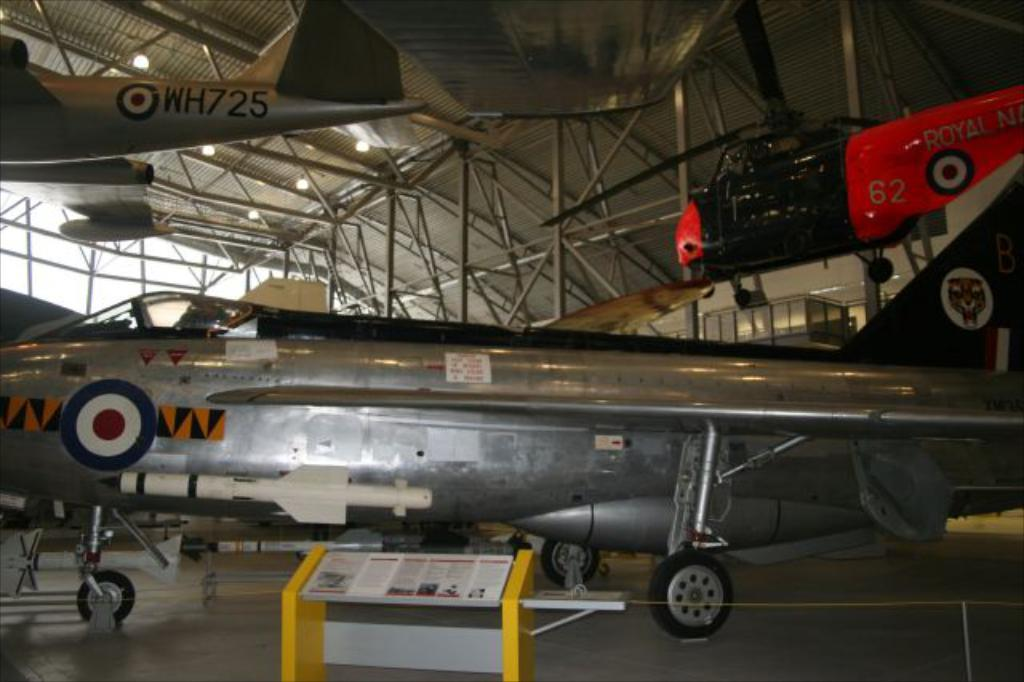<image>
Relay a brief, clear account of the picture shown. a WH725 plane in an airplane hangar with others 